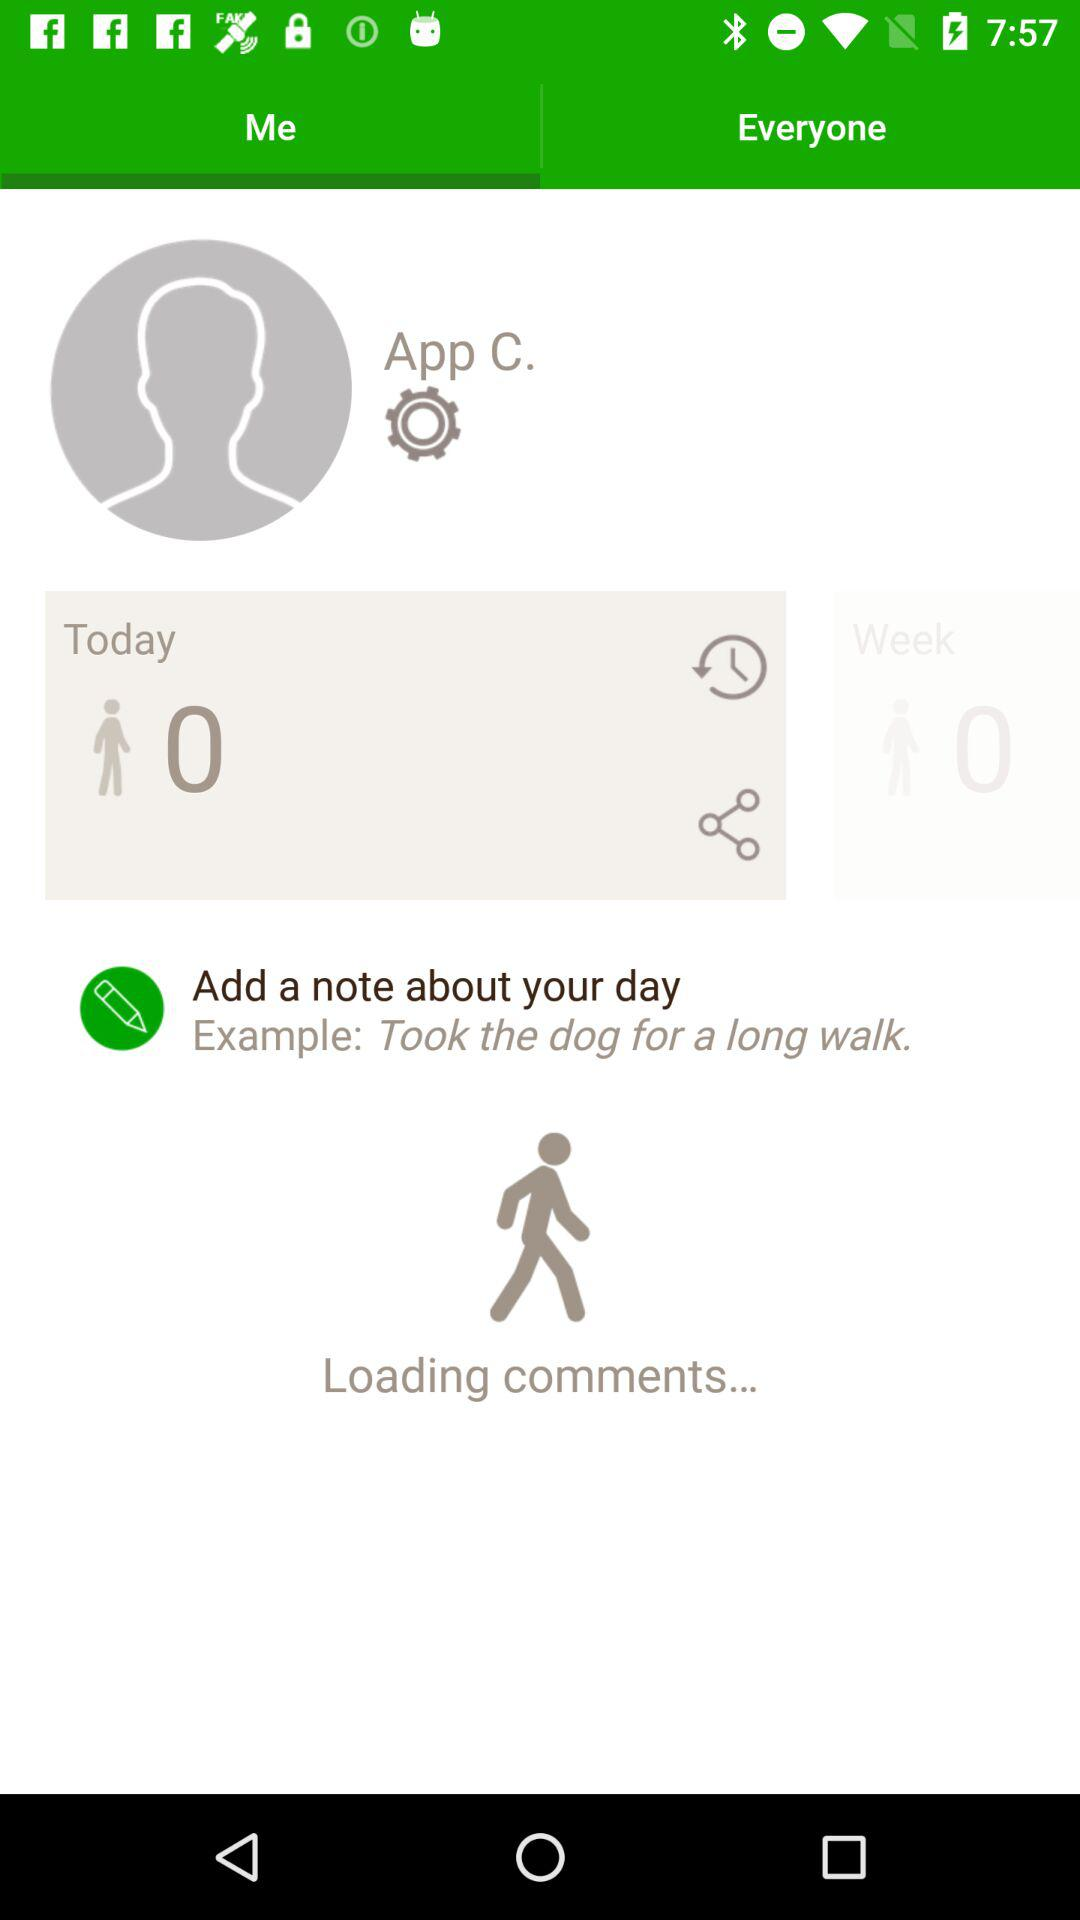What is the selected tab? The selected tab is "Me". 